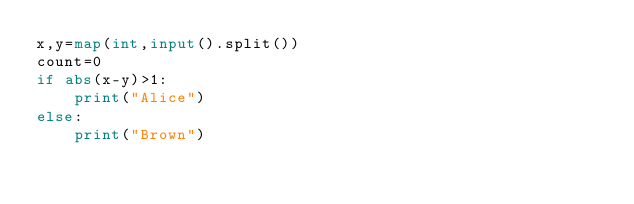Convert code to text. <code><loc_0><loc_0><loc_500><loc_500><_Python_>x,y=map(int,input().split())
count=0
if abs(x-y)>1:
    print("Alice")
else:
    print("Brown")
</code> 